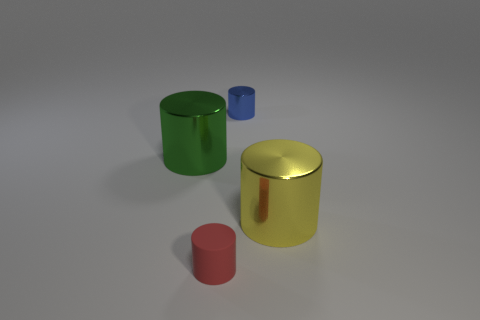Subtract all large green shiny cylinders. How many cylinders are left? 3 Subtract 1 cylinders. How many cylinders are left? 3 Subtract all green cylinders. How many cylinders are left? 3 Add 2 tiny metallic balls. How many objects exist? 6 Subtract all gray cylinders. Subtract all cyan balls. How many cylinders are left? 4 Subtract all brown balls. How many yellow cylinders are left? 1 Subtract all big green cylinders. Subtract all red objects. How many objects are left? 2 Add 2 tiny red things. How many tiny red things are left? 3 Add 3 big cylinders. How many big cylinders exist? 5 Subtract 0 yellow balls. How many objects are left? 4 